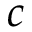Convert formula to latex. <formula><loc_0><loc_0><loc_500><loc_500>c</formula> 